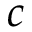Convert formula to latex. <formula><loc_0><loc_0><loc_500><loc_500>c</formula> 